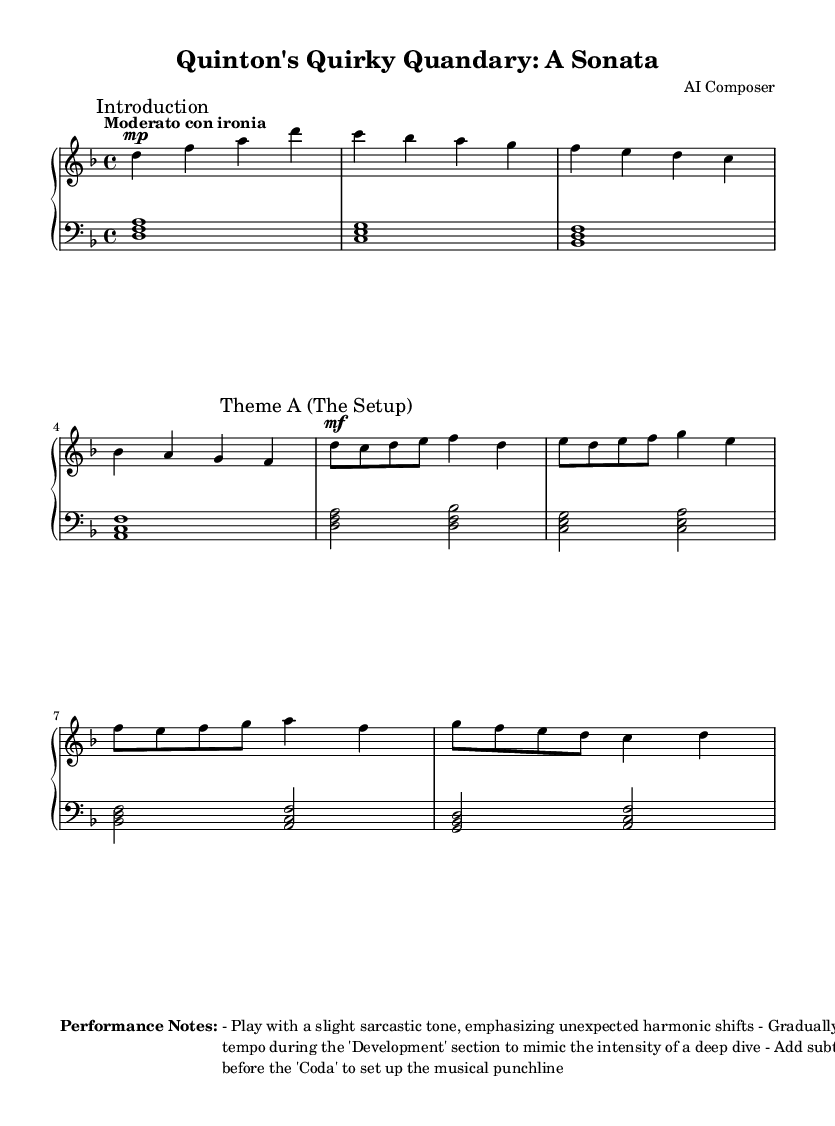What is the key signature of this music? The key signature is indicated at the beginning of the staff. Here, the key of D minor has one flat (B).
Answer: D minor What is the time signature of this music? The time signature is found at the beginning right after the key signature, shown as a fraction. Here, it is 4/4, which means there are four beats per measure.
Answer: 4/4 What tempo marking is used in this piece? The tempo marking is usually found at the start under the title. Here, it states "Moderato con ironia," which suggests a moderate pace with an ironic tone.
Answer: Moderato con ironia How many sections does the music have? The music is divided into two distinct sections: "Introduction" and "Theme A (The Setup)," as marked in the score.
Answer: 2 What is the dynamic marking for the 'Theme A' section? The dynamic marking for the 'Theme A (The Setup)' is found at the beginning of that section and is marked as "mf," which indicates a mezzo-forte dynamic level.
Answer: mf During which section should the performer gradually increase the tempo? According to the performance notes, the performer should gradually increase the tempo during the 'Development' section, suggesting a build-up of intensity inherently associated with that part of the music.
Answer: Development What do the performance notes suggest about the pauses before the 'Coda'? The performance notes explicitly state that subtle pauses should be added before the 'Coda,' which helps create a sense of anticipation and prepares the listener for the final resolution.
Answer: Subtle pauses 